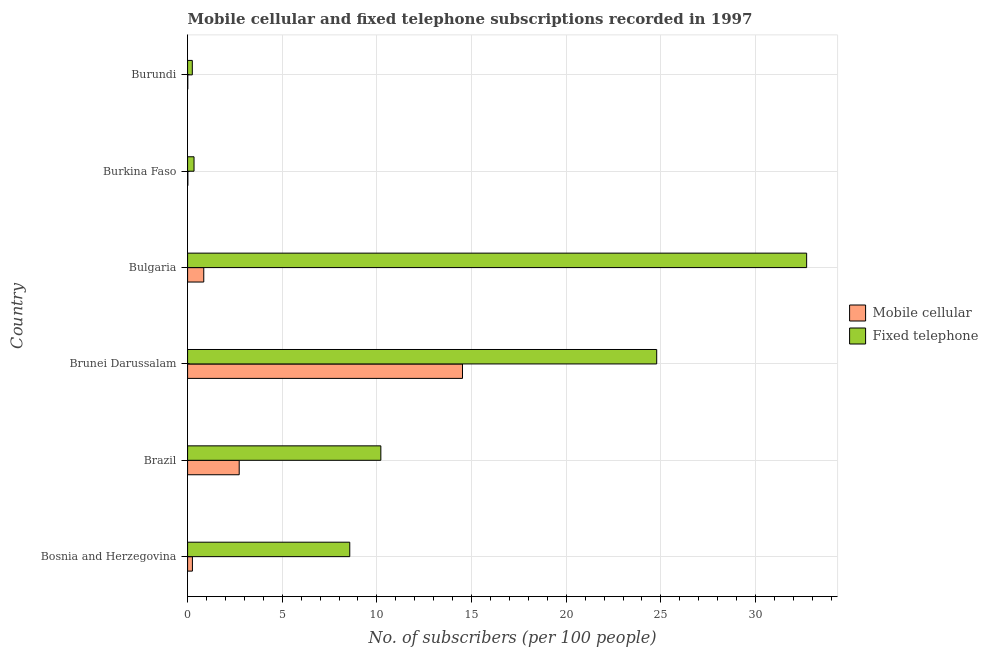Are the number of bars per tick equal to the number of legend labels?
Keep it short and to the point. Yes. Are the number of bars on each tick of the Y-axis equal?
Your answer should be very brief. Yes. How many bars are there on the 2nd tick from the bottom?
Ensure brevity in your answer.  2. What is the label of the 5th group of bars from the top?
Ensure brevity in your answer.  Brazil. In how many cases, is the number of bars for a given country not equal to the number of legend labels?
Your answer should be compact. 0. What is the number of mobile cellular subscribers in Burundi?
Provide a short and direct response. 0.01. Across all countries, what is the maximum number of fixed telephone subscribers?
Provide a short and direct response. 32.7. Across all countries, what is the minimum number of fixed telephone subscribers?
Give a very brief answer. 0.25. In which country was the number of mobile cellular subscribers maximum?
Ensure brevity in your answer.  Brunei Darussalam. In which country was the number of mobile cellular subscribers minimum?
Your answer should be very brief. Burundi. What is the total number of fixed telephone subscribers in the graph?
Your answer should be very brief. 76.84. What is the difference between the number of mobile cellular subscribers in Brazil and that in Bulgaria?
Keep it short and to the point. 1.87. What is the difference between the number of fixed telephone subscribers in Burundi and the number of mobile cellular subscribers in Burkina Faso?
Provide a succinct answer. 0.24. What is the average number of fixed telephone subscribers per country?
Your answer should be very brief. 12.81. What is the difference between the number of mobile cellular subscribers and number of fixed telephone subscribers in Bulgaria?
Your answer should be very brief. -31.84. What is the ratio of the number of mobile cellular subscribers in Bulgaria to that in Burundi?
Provide a short and direct response. 87.84. Is the number of fixed telephone subscribers in Bosnia and Herzegovina less than that in Brunei Darussalam?
Your response must be concise. Yes. Is the difference between the number of fixed telephone subscribers in Bosnia and Herzegovina and Bulgaria greater than the difference between the number of mobile cellular subscribers in Bosnia and Herzegovina and Bulgaria?
Your answer should be compact. No. What is the difference between the highest and the second highest number of mobile cellular subscribers?
Provide a succinct answer. 11.79. What is the difference between the highest and the lowest number of fixed telephone subscribers?
Give a very brief answer. 32.45. In how many countries, is the number of mobile cellular subscribers greater than the average number of mobile cellular subscribers taken over all countries?
Keep it short and to the point. 1. What does the 1st bar from the top in Brazil represents?
Your response must be concise. Fixed telephone. What does the 1st bar from the bottom in Burundi represents?
Offer a very short reply. Mobile cellular. Are all the bars in the graph horizontal?
Provide a short and direct response. Yes. What is the difference between two consecutive major ticks on the X-axis?
Provide a short and direct response. 5. Are the values on the major ticks of X-axis written in scientific E-notation?
Give a very brief answer. No. Does the graph contain any zero values?
Your response must be concise. No. Does the graph contain grids?
Offer a terse response. Yes. How are the legend labels stacked?
Provide a short and direct response. Vertical. What is the title of the graph?
Offer a very short reply. Mobile cellular and fixed telephone subscriptions recorded in 1997. What is the label or title of the X-axis?
Make the answer very short. No. of subscribers (per 100 people). What is the label or title of the Y-axis?
Your answer should be very brief. Country. What is the No. of subscribers (per 100 people) in Mobile cellular in Bosnia and Herzegovina?
Your response must be concise. 0.25. What is the No. of subscribers (per 100 people) in Fixed telephone in Bosnia and Herzegovina?
Provide a short and direct response. 8.57. What is the No. of subscribers (per 100 people) of Mobile cellular in Brazil?
Make the answer very short. 2.73. What is the No. of subscribers (per 100 people) in Fixed telephone in Brazil?
Offer a very short reply. 10.21. What is the No. of subscribers (per 100 people) in Mobile cellular in Brunei Darussalam?
Your answer should be compact. 14.52. What is the No. of subscribers (per 100 people) of Fixed telephone in Brunei Darussalam?
Keep it short and to the point. 24.78. What is the No. of subscribers (per 100 people) in Mobile cellular in Bulgaria?
Your answer should be very brief. 0.85. What is the No. of subscribers (per 100 people) in Fixed telephone in Bulgaria?
Your answer should be compact. 32.7. What is the No. of subscribers (per 100 people) in Mobile cellular in Burkina Faso?
Your answer should be very brief. 0.01. What is the No. of subscribers (per 100 people) in Fixed telephone in Burkina Faso?
Give a very brief answer. 0.34. What is the No. of subscribers (per 100 people) of Mobile cellular in Burundi?
Your answer should be very brief. 0.01. What is the No. of subscribers (per 100 people) of Fixed telephone in Burundi?
Offer a terse response. 0.25. Across all countries, what is the maximum No. of subscribers (per 100 people) in Mobile cellular?
Keep it short and to the point. 14.52. Across all countries, what is the maximum No. of subscribers (per 100 people) of Fixed telephone?
Make the answer very short. 32.7. Across all countries, what is the minimum No. of subscribers (per 100 people) in Mobile cellular?
Ensure brevity in your answer.  0.01. Across all countries, what is the minimum No. of subscribers (per 100 people) of Fixed telephone?
Your answer should be compact. 0.25. What is the total No. of subscribers (per 100 people) of Mobile cellular in the graph?
Provide a short and direct response. 18.38. What is the total No. of subscribers (per 100 people) of Fixed telephone in the graph?
Keep it short and to the point. 76.84. What is the difference between the No. of subscribers (per 100 people) of Mobile cellular in Bosnia and Herzegovina and that in Brazil?
Your response must be concise. -2.47. What is the difference between the No. of subscribers (per 100 people) of Fixed telephone in Bosnia and Herzegovina and that in Brazil?
Give a very brief answer. -1.64. What is the difference between the No. of subscribers (per 100 people) in Mobile cellular in Bosnia and Herzegovina and that in Brunei Darussalam?
Provide a short and direct response. -14.27. What is the difference between the No. of subscribers (per 100 people) of Fixed telephone in Bosnia and Herzegovina and that in Brunei Darussalam?
Make the answer very short. -16.21. What is the difference between the No. of subscribers (per 100 people) of Mobile cellular in Bosnia and Herzegovina and that in Bulgaria?
Ensure brevity in your answer.  -0.6. What is the difference between the No. of subscribers (per 100 people) in Fixed telephone in Bosnia and Herzegovina and that in Bulgaria?
Ensure brevity in your answer.  -24.13. What is the difference between the No. of subscribers (per 100 people) of Mobile cellular in Bosnia and Herzegovina and that in Burkina Faso?
Offer a very short reply. 0.24. What is the difference between the No. of subscribers (per 100 people) of Fixed telephone in Bosnia and Herzegovina and that in Burkina Faso?
Your answer should be very brief. 8.23. What is the difference between the No. of subscribers (per 100 people) of Mobile cellular in Bosnia and Herzegovina and that in Burundi?
Your answer should be compact. 0.24. What is the difference between the No. of subscribers (per 100 people) in Fixed telephone in Bosnia and Herzegovina and that in Burundi?
Your answer should be compact. 8.32. What is the difference between the No. of subscribers (per 100 people) in Mobile cellular in Brazil and that in Brunei Darussalam?
Offer a terse response. -11.79. What is the difference between the No. of subscribers (per 100 people) of Fixed telephone in Brazil and that in Brunei Darussalam?
Give a very brief answer. -14.57. What is the difference between the No. of subscribers (per 100 people) of Mobile cellular in Brazil and that in Bulgaria?
Your response must be concise. 1.87. What is the difference between the No. of subscribers (per 100 people) of Fixed telephone in Brazil and that in Bulgaria?
Your answer should be very brief. -22.49. What is the difference between the No. of subscribers (per 100 people) of Mobile cellular in Brazil and that in Burkina Faso?
Your answer should be compact. 2.71. What is the difference between the No. of subscribers (per 100 people) in Fixed telephone in Brazil and that in Burkina Faso?
Make the answer very short. 9.87. What is the difference between the No. of subscribers (per 100 people) of Mobile cellular in Brazil and that in Burundi?
Make the answer very short. 2.72. What is the difference between the No. of subscribers (per 100 people) in Fixed telephone in Brazil and that in Burundi?
Make the answer very short. 9.96. What is the difference between the No. of subscribers (per 100 people) of Mobile cellular in Brunei Darussalam and that in Bulgaria?
Your answer should be very brief. 13.67. What is the difference between the No. of subscribers (per 100 people) in Fixed telephone in Brunei Darussalam and that in Bulgaria?
Your answer should be compact. -7.92. What is the difference between the No. of subscribers (per 100 people) in Mobile cellular in Brunei Darussalam and that in Burkina Faso?
Your response must be concise. 14.51. What is the difference between the No. of subscribers (per 100 people) of Fixed telephone in Brunei Darussalam and that in Burkina Faso?
Provide a succinct answer. 24.44. What is the difference between the No. of subscribers (per 100 people) of Mobile cellular in Brunei Darussalam and that in Burundi?
Make the answer very short. 14.51. What is the difference between the No. of subscribers (per 100 people) of Fixed telephone in Brunei Darussalam and that in Burundi?
Ensure brevity in your answer.  24.53. What is the difference between the No. of subscribers (per 100 people) in Mobile cellular in Bulgaria and that in Burkina Faso?
Your response must be concise. 0.84. What is the difference between the No. of subscribers (per 100 people) in Fixed telephone in Bulgaria and that in Burkina Faso?
Make the answer very short. 32.36. What is the difference between the No. of subscribers (per 100 people) in Mobile cellular in Bulgaria and that in Burundi?
Your response must be concise. 0.84. What is the difference between the No. of subscribers (per 100 people) of Fixed telephone in Bulgaria and that in Burundi?
Ensure brevity in your answer.  32.45. What is the difference between the No. of subscribers (per 100 people) of Mobile cellular in Burkina Faso and that in Burundi?
Keep it short and to the point. 0. What is the difference between the No. of subscribers (per 100 people) in Fixed telephone in Burkina Faso and that in Burundi?
Give a very brief answer. 0.09. What is the difference between the No. of subscribers (per 100 people) in Mobile cellular in Bosnia and Herzegovina and the No. of subscribers (per 100 people) in Fixed telephone in Brazil?
Your answer should be compact. -9.95. What is the difference between the No. of subscribers (per 100 people) of Mobile cellular in Bosnia and Herzegovina and the No. of subscribers (per 100 people) of Fixed telephone in Brunei Darussalam?
Offer a very short reply. -24.52. What is the difference between the No. of subscribers (per 100 people) in Mobile cellular in Bosnia and Herzegovina and the No. of subscribers (per 100 people) in Fixed telephone in Bulgaria?
Offer a very short reply. -32.44. What is the difference between the No. of subscribers (per 100 people) of Mobile cellular in Bosnia and Herzegovina and the No. of subscribers (per 100 people) of Fixed telephone in Burkina Faso?
Ensure brevity in your answer.  -0.09. What is the difference between the No. of subscribers (per 100 people) of Mobile cellular in Bosnia and Herzegovina and the No. of subscribers (per 100 people) of Fixed telephone in Burundi?
Provide a short and direct response. 0.01. What is the difference between the No. of subscribers (per 100 people) of Mobile cellular in Brazil and the No. of subscribers (per 100 people) of Fixed telephone in Brunei Darussalam?
Your answer should be very brief. -22.05. What is the difference between the No. of subscribers (per 100 people) in Mobile cellular in Brazil and the No. of subscribers (per 100 people) in Fixed telephone in Bulgaria?
Make the answer very short. -29.97. What is the difference between the No. of subscribers (per 100 people) of Mobile cellular in Brazil and the No. of subscribers (per 100 people) of Fixed telephone in Burkina Faso?
Your response must be concise. 2.39. What is the difference between the No. of subscribers (per 100 people) of Mobile cellular in Brazil and the No. of subscribers (per 100 people) of Fixed telephone in Burundi?
Keep it short and to the point. 2.48. What is the difference between the No. of subscribers (per 100 people) in Mobile cellular in Brunei Darussalam and the No. of subscribers (per 100 people) in Fixed telephone in Bulgaria?
Your response must be concise. -18.18. What is the difference between the No. of subscribers (per 100 people) of Mobile cellular in Brunei Darussalam and the No. of subscribers (per 100 people) of Fixed telephone in Burkina Faso?
Offer a terse response. 14.18. What is the difference between the No. of subscribers (per 100 people) in Mobile cellular in Brunei Darussalam and the No. of subscribers (per 100 people) in Fixed telephone in Burundi?
Offer a terse response. 14.27. What is the difference between the No. of subscribers (per 100 people) of Mobile cellular in Bulgaria and the No. of subscribers (per 100 people) of Fixed telephone in Burkina Faso?
Ensure brevity in your answer.  0.51. What is the difference between the No. of subscribers (per 100 people) in Mobile cellular in Bulgaria and the No. of subscribers (per 100 people) in Fixed telephone in Burundi?
Make the answer very short. 0.6. What is the difference between the No. of subscribers (per 100 people) of Mobile cellular in Burkina Faso and the No. of subscribers (per 100 people) of Fixed telephone in Burundi?
Keep it short and to the point. -0.23. What is the average No. of subscribers (per 100 people) in Mobile cellular per country?
Your answer should be compact. 3.06. What is the average No. of subscribers (per 100 people) in Fixed telephone per country?
Your response must be concise. 12.81. What is the difference between the No. of subscribers (per 100 people) in Mobile cellular and No. of subscribers (per 100 people) in Fixed telephone in Bosnia and Herzegovina?
Offer a terse response. -8.31. What is the difference between the No. of subscribers (per 100 people) of Mobile cellular and No. of subscribers (per 100 people) of Fixed telephone in Brazil?
Make the answer very short. -7.48. What is the difference between the No. of subscribers (per 100 people) of Mobile cellular and No. of subscribers (per 100 people) of Fixed telephone in Brunei Darussalam?
Provide a short and direct response. -10.26. What is the difference between the No. of subscribers (per 100 people) in Mobile cellular and No. of subscribers (per 100 people) in Fixed telephone in Bulgaria?
Keep it short and to the point. -31.84. What is the difference between the No. of subscribers (per 100 people) of Mobile cellular and No. of subscribers (per 100 people) of Fixed telephone in Burkina Faso?
Make the answer very short. -0.33. What is the difference between the No. of subscribers (per 100 people) of Mobile cellular and No. of subscribers (per 100 people) of Fixed telephone in Burundi?
Your answer should be very brief. -0.24. What is the ratio of the No. of subscribers (per 100 people) of Mobile cellular in Bosnia and Herzegovina to that in Brazil?
Your answer should be compact. 0.09. What is the ratio of the No. of subscribers (per 100 people) of Fixed telephone in Bosnia and Herzegovina to that in Brazil?
Your response must be concise. 0.84. What is the ratio of the No. of subscribers (per 100 people) of Mobile cellular in Bosnia and Herzegovina to that in Brunei Darussalam?
Your answer should be very brief. 0.02. What is the ratio of the No. of subscribers (per 100 people) in Fixed telephone in Bosnia and Herzegovina to that in Brunei Darussalam?
Your response must be concise. 0.35. What is the ratio of the No. of subscribers (per 100 people) of Mobile cellular in Bosnia and Herzegovina to that in Bulgaria?
Ensure brevity in your answer.  0.3. What is the ratio of the No. of subscribers (per 100 people) in Fixed telephone in Bosnia and Herzegovina to that in Bulgaria?
Your answer should be compact. 0.26. What is the ratio of the No. of subscribers (per 100 people) in Mobile cellular in Bosnia and Herzegovina to that in Burkina Faso?
Your answer should be compact. 18.06. What is the ratio of the No. of subscribers (per 100 people) in Fixed telephone in Bosnia and Herzegovina to that in Burkina Faso?
Provide a short and direct response. 25.2. What is the ratio of the No. of subscribers (per 100 people) in Mobile cellular in Bosnia and Herzegovina to that in Burundi?
Ensure brevity in your answer.  26.19. What is the ratio of the No. of subscribers (per 100 people) in Fixed telephone in Bosnia and Herzegovina to that in Burundi?
Your response must be concise. 34.39. What is the ratio of the No. of subscribers (per 100 people) in Mobile cellular in Brazil to that in Brunei Darussalam?
Provide a short and direct response. 0.19. What is the ratio of the No. of subscribers (per 100 people) of Fixed telephone in Brazil to that in Brunei Darussalam?
Ensure brevity in your answer.  0.41. What is the ratio of the No. of subscribers (per 100 people) in Mobile cellular in Brazil to that in Bulgaria?
Make the answer very short. 3.19. What is the ratio of the No. of subscribers (per 100 people) in Fixed telephone in Brazil to that in Bulgaria?
Your answer should be very brief. 0.31. What is the ratio of the No. of subscribers (per 100 people) of Mobile cellular in Brazil to that in Burkina Faso?
Provide a short and direct response. 193.41. What is the ratio of the No. of subscribers (per 100 people) in Fixed telephone in Brazil to that in Burkina Faso?
Offer a very short reply. 30.02. What is the ratio of the No. of subscribers (per 100 people) in Mobile cellular in Brazil to that in Burundi?
Ensure brevity in your answer.  280.48. What is the ratio of the No. of subscribers (per 100 people) in Fixed telephone in Brazil to that in Burundi?
Give a very brief answer. 40.98. What is the ratio of the No. of subscribers (per 100 people) of Mobile cellular in Brunei Darussalam to that in Bulgaria?
Keep it short and to the point. 17.01. What is the ratio of the No. of subscribers (per 100 people) of Fixed telephone in Brunei Darussalam to that in Bulgaria?
Provide a short and direct response. 0.76. What is the ratio of the No. of subscribers (per 100 people) in Mobile cellular in Brunei Darussalam to that in Burkina Faso?
Your answer should be compact. 1030.35. What is the ratio of the No. of subscribers (per 100 people) of Fixed telephone in Brunei Darussalam to that in Burkina Faso?
Your answer should be compact. 72.88. What is the ratio of the No. of subscribers (per 100 people) in Mobile cellular in Brunei Darussalam to that in Burundi?
Your answer should be compact. 1494.19. What is the ratio of the No. of subscribers (per 100 people) of Fixed telephone in Brunei Darussalam to that in Burundi?
Your answer should be very brief. 99.47. What is the ratio of the No. of subscribers (per 100 people) of Mobile cellular in Bulgaria to that in Burkina Faso?
Offer a very short reply. 60.58. What is the ratio of the No. of subscribers (per 100 people) of Fixed telephone in Bulgaria to that in Burkina Faso?
Provide a short and direct response. 96.18. What is the ratio of the No. of subscribers (per 100 people) of Mobile cellular in Bulgaria to that in Burundi?
Your answer should be very brief. 87.85. What is the ratio of the No. of subscribers (per 100 people) of Fixed telephone in Bulgaria to that in Burundi?
Your response must be concise. 131.26. What is the ratio of the No. of subscribers (per 100 people) in Mobile cellular in Burkina Faso to that in Burundi?
Your answer should be very brief. 1.45. What is the ratio of the No. of subscribers (per 100 people) of Fixed telephone in Burkina Faso to that in Burundi?
Provide a short and direct response. 1.36. What is the difference between the highest and the second highest No. of subscribers (per 100 people) of Mobile cellular?
Keep it short and to the point. 11.79. What is the difference between the highest and the second highest No. of subscribers (per 100 people) in Fixed telephone?
Provide a succinct answer. 7.92. What is the difference between the highest and the lowest No. of subscribers (per 100 people) of Mobile cellular?
Provide a short and direct response. 14.51. What is the difference between the highest and the lowest No. of subscribers (per 100 people) in Fixed telephone?
Give a very brief answer. 32.45. 